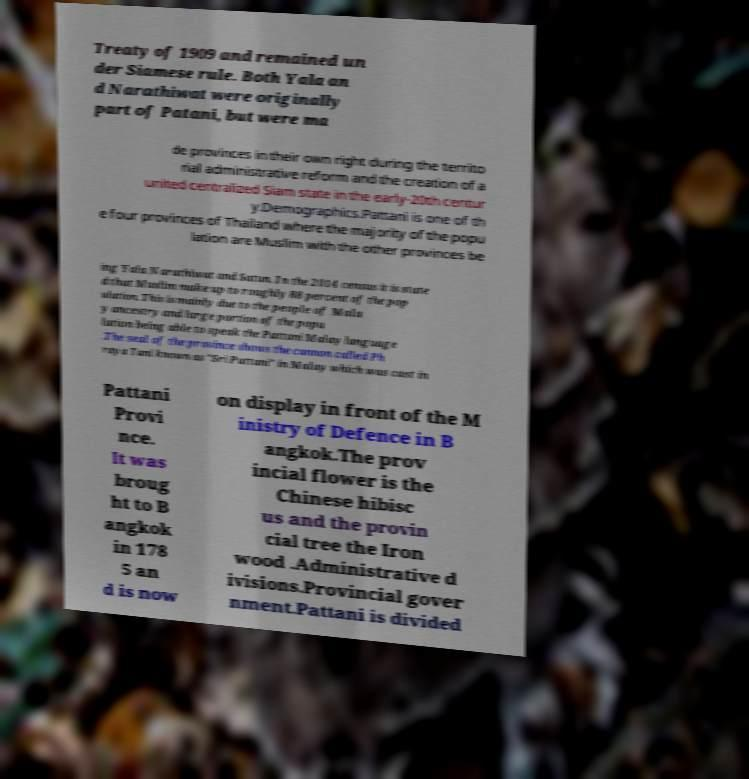Can you accurately transcribe the text from the provided image for me? Treaty of 1909 and remained un der Siamese rule. Both Yala an d Narathiwat were originally part of Patani, but were ma de provinces in their own right during the territo rial administrative reform and the creation of a united centralized Siam state in the early-20th centur y.Demographics.Pattani is one of th e four provinces of Thailand where the majority of the popu lation are Muslim with the other provinces be ing Yala Narathiwat and Satun. In the 2014 census it is state d that Muslim make up to roughly 88 percent of the pop ulation. This is mainly due to the people of Mala y ancestry and large portion of the popu lation being able to speak the Pattani Malay language .The seal of the province shows the cannon called Ph raya Tani known as "Sri Pattani" in Malay which was cast in Pattani Provi nce. It was broug ht to B angkok in 178 5 an d is now on display in front of the M inistry of Defence in B angkok.The prov incial flower is the Chinese hibisc us and the provin cial tree the Iron wood .Administrative d ivisions.Provincial gover nment.Pattani is divided 